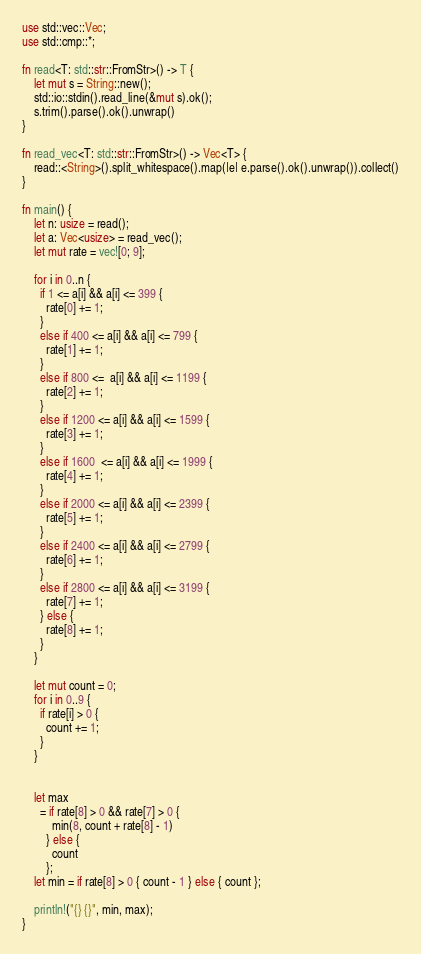<code> <loc_0><loc_0><loc_500><loc_500><_Rust_>use std::vec::Vec;
use std::cmp::*;

fn read<T: std::str::FromStr>() -> T {
    let mut s = String::new();
    std::io::stdin().read_line(&mut s).ok();
    s.trim().parse().ok().unwrap()
}

fn read_vec<T: std::str::FromStr>() -> Vec<T> {
    read::<String>().split_whitespace().map(|e| e.parse().ok().unwrap()).collect()
}

fn main() {
    let n: usize = read();
    let a: Vec<usize> = read_vec();
    let mut rate = vec![0; 9];

    for i in 0..n {
      if 1 <= a[i] && a[i] <= 399 {
        rate[0] += 1;
      }
      else if 400 <= a[i] && a[i] <= 799 {
        rate[1] += 1;
      }
      else if 800 <=  a[i] && a[i] <= 1199 {
        rate[2] += 1;
      }
      else if 1200 <= a[i] && a[i] <= 1599 {
        rate[3] += 1;
      }
      else if 1600  <= a[i] && a[i] <= 1999 {
        rate[4] += 1;
      }
      else if 2000 <= a[i] && a[i] <= 2399 {
        rate[5] += 1;
      }
      else if 2400 <= a[i] && a[i] <= 2799 {
        rate[6] += 1;
      }
      else if 2800 <= a[i] && a[i] <= 3199 {
        rate[7] += 1;
      } else {
        rate[8] += 1;
      }
    }

    let mut count = 0;
    for i in 0..9 {
      if rate[i] > 0 {
        count += 1;
      }
    }


    let max
      = if rate[8] > 0 && rate[7] > 0 {
          min(8, count + rate[8] - 1)
        } else {
          count
        };
    let min = if rate[8] > 0 { count - 1 } else { count };

    println!("{} {}", min, max);
}

</code> 